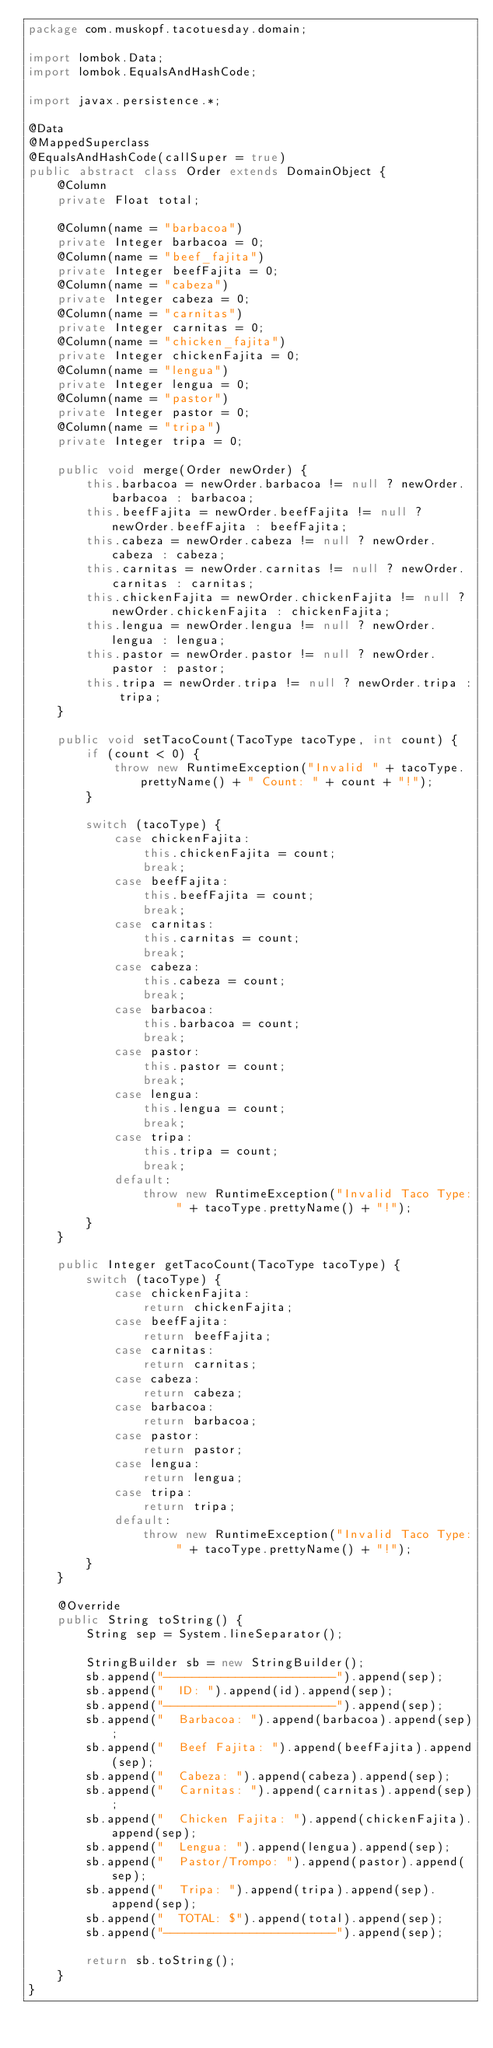<code> <loc_0><loc_0><loc_500><loc_500><_Java_>package com.muskopf.tacotuesday.domain;

import lombok.Data;
import lombok.EqualsAndHashCode;

import javax.persistence.*;

@Data
@MappedSuperclass
@EqualsAndHashCode(callSuper = true)
public abstract class Order extends DomainObject {
    @Column
    private Float total;

    @Column(name = "barbacoa")
    private Integer barbacoa = 0;
    @Column(name = "beef_fajita")
    private Integer beefFajita = 0;
    @Column(name = "cabeza")
    private Integer cabeza = 0;
    @Column(name = "carnitas")
    private Integer carnitas = 0;
    @Column(name = "chicken_fajita")
    private Integer chickenFajita = 0;
    @Column(name = "lengua")
    private Integer lengua = 0;
    @Column(name = "pastor")
    private Integer pastor = 0;
    @Column(name = "tripa")
    private Integer tripa = 0;

    public void merge(Order newOrder) {
        this.barbacoa = newOrder.barbacoa != null ? newOrder.barbacoa : barbacoa;
        this.beefFajita = newOrder.beefFajita != null ? newOrder.beefFajita : beefFajita;
        this.cabeza = newOrder.cabeza != null ? newOrder.cabeza : cabeza;
        this.carnitas = newOrder.carnitas != null ? newOrder.carnitas : carnitas;
        this.chickenFajita = newOrder.chickenFajita != null ? newOrder.chickenFajita : chickenFajita;
        this.lengua = newOrder.lengua != null ? newOrder.lengua : lengua;
        this.pastor = newOrder.pastor != null ? newOrder.pastor : pastor;
        this.tripa = newOrder.tripa != null ? newOrder.tripa : tripa;
    }

    public void setTacoCount(TacoType tacoType, int count) {
        if (count < 0) {
            throw new RuntimeException("Invalid " + tacoType.prettyName() + " Count: " + count + "!");
        }

        switch (tacoType) {
            case chickenFajita:
                this.chickenFajita = count;
                break;
            case beefFajita:
                this.beefFajita = count;
                break;
            case carnitas:
                this.carnitas = count;
                break;
            case cabeza:
                this.cabeza = count;
                break;
            case barbacoa:
                this.barbacoa = count;
                break;
            case pastor:
                this.pastor = count;
                break;
            case lengua:
                this.lengua = count;
                break;
            case tripa:
                this.tripa = count;
                break;
            default:
                throw new RuntimeException("Invalid Taco Type: " + tacoType.prettyName() + "!");
        }
    }

    public Integer getTacoCount(TacoType tacoType) {
        switch (tacoType) {
            case chickenFajita:
                return chickenFajita;
            case beefFajita:
                return beefFajita;
            case carnitas:
                return carnitas;
            case cabeza:
                return cabeza;
            case barbacoa:
                return barbacoa;
            case pastor:
                return pastor;
            case lengua:
                return lengua;
            case tripa:
                return tripa;
            default:
                throw new RuntimeException("Invalid Taco Type: " + tacoType.prettyName() + "!");
        }
    }

    @Override
    public String toString() {
        String sep = System.lineSeparator();

        StringBuilder sb = new StringBuilder();
        sb.append("------------------------").append(sep);
        sb.append("  ID: ").append(id).append(sep);
        sb.append("------------------------").append(sep);
        sb.append("  Barbacoa: ").append(barbacoa).append(sep);
        sb.append("  Beef Fajita: ").append(beefFajita).append(sep);
        sb.append("  Cabeza: ").append(cabeza).append(sep);
        sb.append("  Carnitas: ").append(carnitas).append(sep);
        sb.append("  Chicken Fajita: ").append(chickenFajita).append(sep);
        sb.append("  Lengua: ").append(lengua).append(sep);
        sb.append("  Pastor/Trompo: ").append(pastor).append(sep);
        sb.append("  Tripa: ").append(tripa).append(sep).append(sep);
        sb.append("  TOTAL: $").append(total).append(sep);
        sb.append("------------------------").append(sep);

        return sb.toString();
    }
}
</code> 